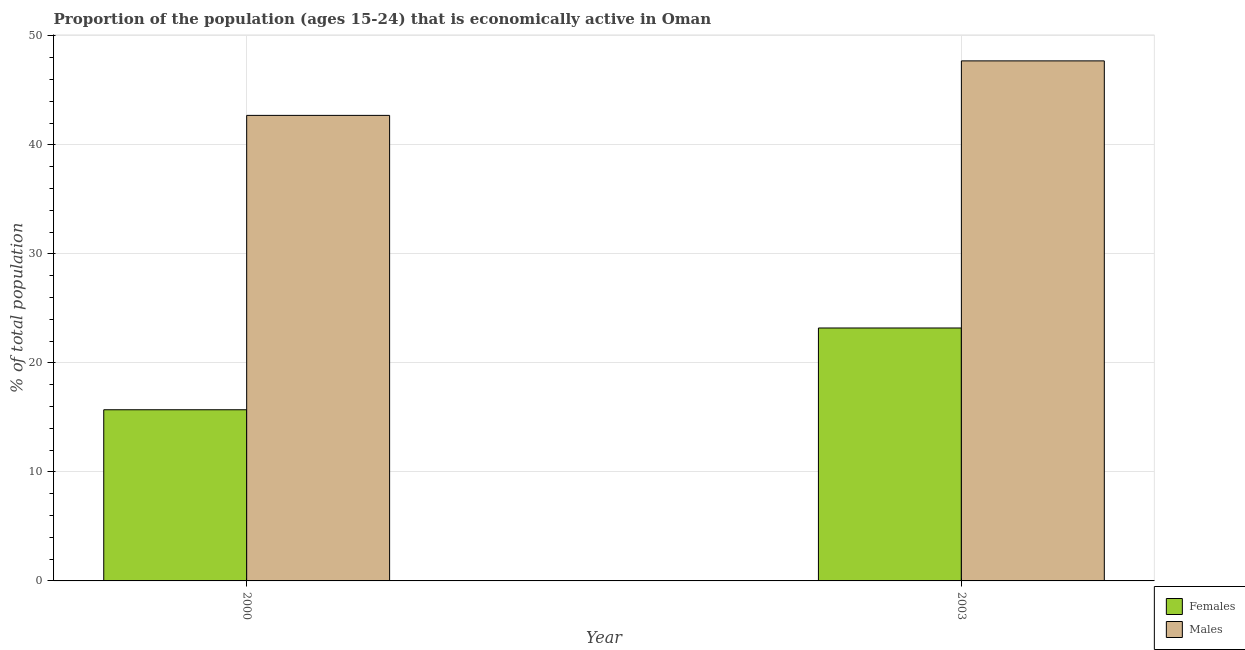How many groups of bars are there?
Your response must be concise. 2. What is the label of the 1st group of bars from the left?
Your response must be concise. 2000. What is the percentage of economically active female population in 2000?
Provide a succinct answer. 15.7. Across all years, what is the maximum percentage of economically active female population?
Make the answer very short. 23.2. Across all years, what is the minimum percentage of economically active male population?
Make the answer very short. 42.7. What is the total percentage of economically active male population in the graph?
Your response must be concise. 90.4. What is the difference between the percentage of economically active female population in 2000 and that in 2003?
Your response must be concise. -7.5. What is the difference between the percentage of economically active male population in 2003 and the percentage of economically active female population in 2000?
Offer a very short reply. 5. What is the average percentage of economically active male population per year?
Offer a terse response. 45.2. In how many years, is the percentage of economically active male population greater than 22 %?
Give a very brief answer. 2. What is the ratio of the percentage of economically active male population in 2000 to that in 2003?
Make the answer very short. 0.9. In how many years, is the percentage of economically active female population greater than the average percentage of economically active female population taken over all years?
Provide a succinct answer. 1. What does the 1st bar from the left in 2000 represents?
Your response must be concise. Females. What does the 1st bar from the right in 2003 represents?
Ensure brevity in your answer.  Males. What is the difference between two consecutive major ticks on the Y-axis?
Offer a very short reply. 10. Does the graph contain any zero values?
Your answer should be very brief. No. Where does the legend appear in the graph?
Offer a very short reply. Bottom right. How many legend labels are there?
Your answer should be very brief. 2. How are the legend labels stacked?
Give a very brief answer. Vertical. What is the title of the graph?
Give a very brief answer. Proportion of the population (ages 15-24) that is economically active in Oman. Does "Death rate" appear as one of the legend labels in the graph?
Make the answer very short. No. What is the label or title of the X-axis?
Provide a succinct answer. Year. What is the label or title of the Y-axis?
Offer a very short reply. % of total population. What is the % of total population of Females in 2000?
Your answer should be very brief. 15.7. What is the % of total population in Males in 2000?
Provide a short and direct response. 42.7. What is the % of total population of Females in 2003?
Provide a succinct answer. 23.2. What is the % of total population of Males in 2003?
Offer a very short reply. 47.7. Across all years, what is the maximum % of total population in Females?
Provide a succinct answer. 23.2. Across all years, what is the maximum % of total population of Males?
Provide a short and direct response. 47.7. Across all years, what is the minimum % of total population of Females?
Ensure brevity in your answer.  15.7. Across all years, what is the minimum % of total population in Males?
Your answer should be very brief. 42.7. What is the total % of total population in Females in the graph?
Your answer should be very brief. 38.9. What is the total % of total population in Males in the graph?
Your answer should be very brief. 90.4. What is the difference between the % of total population in Males in 2000 and that in 2003?
Offer a terse response. -5. What is the difference between the % of total population in Females in 2000 and the % of total population in Males in 2003?
Your answer should be compact. -32. What is the average % of total population in Females per year?
Your answer should be very brief. 19.45. What is the average % of total population in Males per year?
Your answer should be very brief. 45.2. In the year 2000, what is the difference between the % of total population in Females and % of total population in Males?
Give a very brief answer. -27. In the year 2003, what is the difference between the % of total population of Females and % of total population of Males?
Give a very brief answer. -24.5. What is the ratio of the % of total population in Females in 2000 to that in 2003?
Your response must be concise. 0.68. What is the ratio of the % of total population of Males in 2000 to that in 2003?
Offer a very short reply. 0.9. What is the difference between the highest and the second highest % of total population in Males?
Provide a short and direct response. 5. What is the difference between the highest and the lowest % of total population in Males?
Ensure brevity in your answer.  5. 